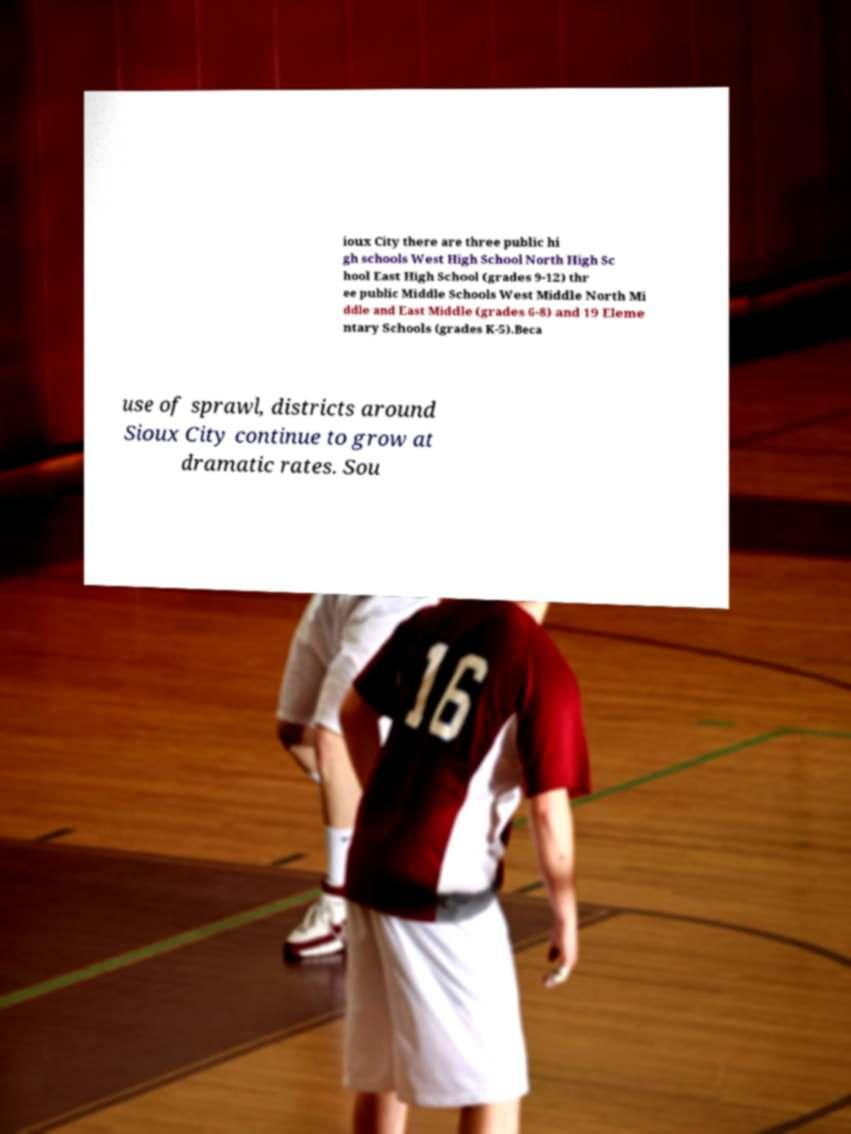There's text embedded in this image that I need extracted. Can you transcribe it verbatim? ioux City there are three public hi gh schools West High School North High Sc hool East High School (grades 9-12) thr ee public Middle Schools West Middle North Mi ddle and East Middle (grades 6-8) and 19 Eleme ntary Schools (grades K-5).Beca use of sprawl, districts around Sioux City continue to grow at dramatic rates. Sou 